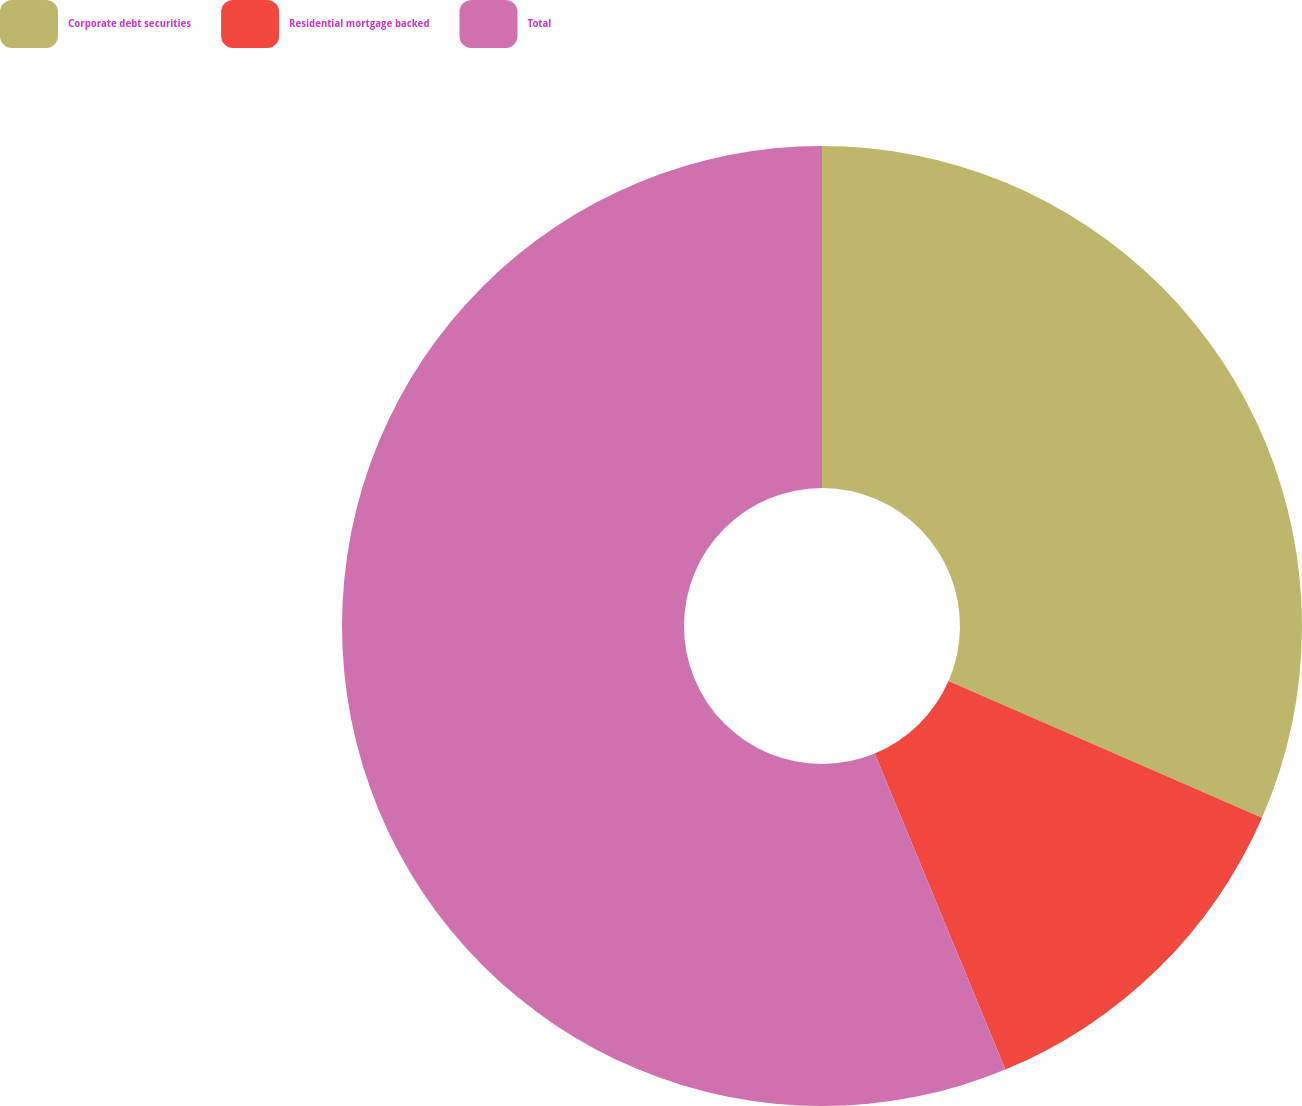Convert chart to OTSL. <chart><loc_0><loc_0><loc_500><loc_500><pie_chart><fcel>Corporate debt securities<fcel>Residential mortgage backed<fcel>Total<nl><fcel>31.54%<fcel>12.22%<fcel>56.24%<nl></chart> 